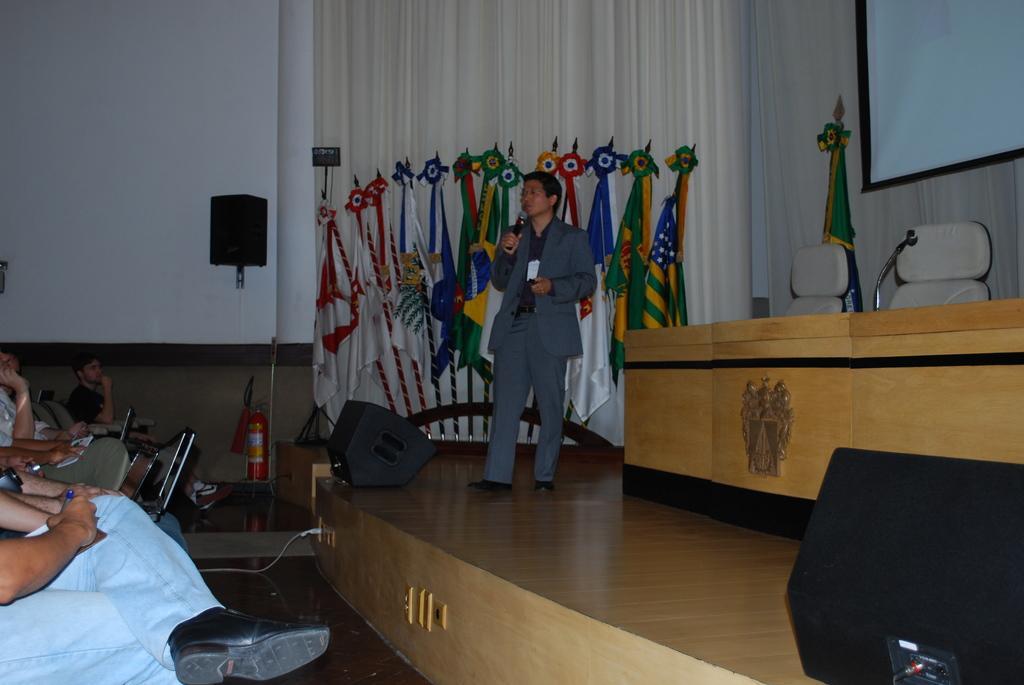How would you summarize this image in a sentence or two? In this picture there is a man who is standing in the center of the image, by holding a mic in his hand and there are other people those who are sitting on the left side of the image, there is a projector screen in the top right side of the image and there are flags in the background area of the image, there are chairs, speakers, a mic on a desk and a cylinder in the image. 